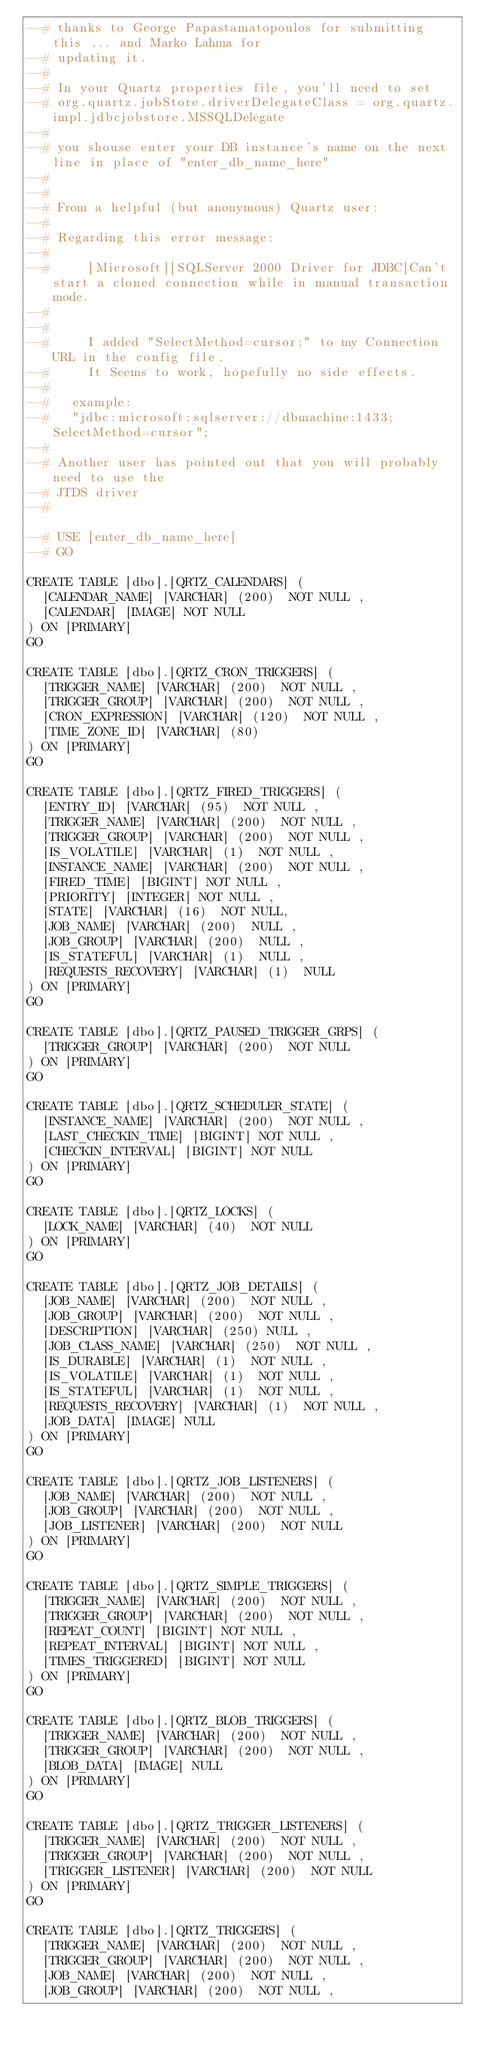<code> <loc_0><loc_0><loc_500><loc_500><_SQL_>--# thanks to George Papastamatopoulos for submitting this ... and Marko Lahma for
--# updating it.
--#
--# In your Quartz properties file, you'll need to set 
--# org.quartz.jobStore.driverDelegateClass = org.quartz.impl.jdbcjobstore.MSSQLDelegate
--#
--# you shouse enter your DB instance's name on the next line in place of "enter_db_name_here"
--#
--#
--# From a helpful (but anonymous) Quartz user:
--#
--# Regarding this error message:  
--#
--#     [Microsoft][SQLServer 2000 Driver for JDBC]Can't start a cloned connection while in manual transaction mode.
--#
--#
--#     I added "SelectMethod=cursor;" to my Connection URL in the config file. 
--#     It Seems to work, hopefully no side effects.
--#
--#		example:
--#		"jdbc:microsoft:sqlserver://dbmachine:1433;SelectMethod=cursor"; 
--#
--# Another user has pointed out that you will probably need to use the 
--# JTDS driver
--#

--# USE [enter_db_name_here]
--# GO

CREATE TABLE [dbo].[QRTZ_CALENDARS] (
  [CALENDAR_NAME] [VARCHAR] (200)  NOT NULL ,
  [CALENDAR] [IMAGE] NOT NULL
) ON [PRIMARY]
GO

CREATE TABLE [dbo].[QRTZ_CRON_TRIGGERS] (
  [TRIGGER_NAME] [VARCHAR] (200)  NOT NULL ,
  [TRIGGER_GROUP] [VARCHAR] (200)  NOT NULL ,
  [CRON_EXPRESSION] [VARCHAR] (120)  NOT NULL ,
  [TIME_ZONE_ID] [VARCHAR] (80) 
) ON [PRIMARY]
GO

CREATE TABLE [dbo].[QRTZ_FIRED_TRIGGERS] (
  [ENTRY_ID] [VARCHAR] (95)  NOT NULL ,
  [TRIGGER_NAME] [VARCHAR] (200)  NOT NULL ,
  [TRIGGER_GROUP] [VARCHAR] (200)  NOT NULL ,
  [IS_VOLATILE] [VARCHAR] (1)  NOT NULL ,
  [INSTANCE_NAME] [VARCHAR] (200)  NOT NULL ,
  [FIRED_TIME] [BIGINT] NOT NULL ,
  [PRIORITY] [INTEGER] NOT NULL ,
  [STATE] [VARCHAR] (16)  NOT NULL,
  [JOB_NAME] [VARCHAR] (200)  NULL ,
  [JOB_GROUP] [VARCHAR] (200)  NULL ,
  [IS_STATEFUL] [VARCHAR] (1)  NULL ,
  [REQUESTS_RECOVERY] [VARCHAR] (1)  NULL 
) ON [PRIMARY]
GO

CREATE TABLE [dbo].[QRTZ_PAUSED_TRIGGER_GRPS] (
  [TRIGGER_GROUP] [VARCHAR] (200)  NOT NULL 
) ON [PRIMARY]
GO

CREATE TABLE [dbo].[QRTZ_SCHEDULER_STATE] (
  [INSTANCE_NAME] [VARCHAR] (200)  NOT NULL ,
  [LAST_CHECKIN_TIME] [BIGINT] NOT NULL ,
  [CHECKIN_INTERVAL] [BIGINT] NOT NULL
) ON [PRIMARY]
GO

CREATE TABLE [dbo].[QRTZ_LOCKS] (
  [LOCK_NAME] [VARCHAR] (40)  NOT NULL 
) ON [PRIMARY]
GO

CREATE TABLE [dbo].[QRTZ_JOB_DETAILS] (
  [JOB_NAME] [VARCHAR] (200)  NOT NULL ,
  [JOB_GROUP] [VARCHAR] (200)  NOT NULL ,
  [DESCRIPTION] [VARCHAR] (250) NULL ,
  [JOB_CLASS_NAME] [VARCHAR] (250)  NOT NULL ,
  [IS_DURABLE] [VARCHAR] (1)  NOT NULL ,
  [IS_VOLATILE] [VARCHAR] (1)  NOT NULL ,
  [IS_STATEFUL] [VARCHAR] (1)  NOT NULL ,
  [REQUESTS_RECOVERY] [VARCHAR] (1)  NOT NULL ,
  [JOB_DATA] [IMAGE] NULL
) ON [PRIMARY]
GO

CREATE TABLE [dbo].[QRTZ_JOB_LISTENERS] (
  [JOB_NAME] [VARCHAR] (200)  NOT NULL ,
  [JOB_GROUP] [VARCHAR] (200)  NOT NULL ,
  [JOB_LISTENER] [VARCHAR] (200)  NOT NULL
) ON [PRIMARY]
GO

CREATE TABLE [dbo].[QRTZ_SIMPLE_TRIGGERS] (
  [TRIGGER_NAME] [VARCHAR] (200)  NOT NULL ,
  [TRIGGER_GROUP] [VARCHAR] (200)  NOT NULL ,
  [REPEAT_COUNT] [BIGINT] NOT NULL ,
  [REPEAT_INTERVAL] [BIGINT] NOT NULL ,
  [TIMES_TRIGGERED] [BIGINT] NOT NULL
) ON [PRIMARY]
GO

CREATE TABLE [dbo].[QRTZ_BLOB_TRIGGERS] (
  [TRIGGER_NAME] [VARCHAR] (200)  NOT NULL ,
  [TRIGGER_GROUP] [VARCHAR] (200)  NOT NULL ,
  [BLOB_DATA] [IMAGE] NULL
) ON [PRIMARY]
GO

CREATE TABLE [dbo].[QRTZ_TRIGGER_LISTENERS] (
  [TRIGGER_NAME] [VARCHAR] (200)  NOT NULL ,
  [TRIGGER_GROUP] [VARCHAR] (200)  NOT NULL ,
  [TRIGGER_LISTENER] [VARCHAR] (200)  NOT NULL
) ON [PRIMARY]
GO

CREATE TABLE [dbo].[QRTZ_TRIGGERS] (
  [TRIGGER_NAME] [VARCHAR] (200)  NOT NULL ,
  [TRIGGER_GROUP] [VARCHAR] (200)  NOT NULL ,
  [JOB_NAME] [VARCHAR] (200)  NOT NULL ,
  [JOB_GROUP] [VARCHAR] (200)  NOT NULL ,</code> 